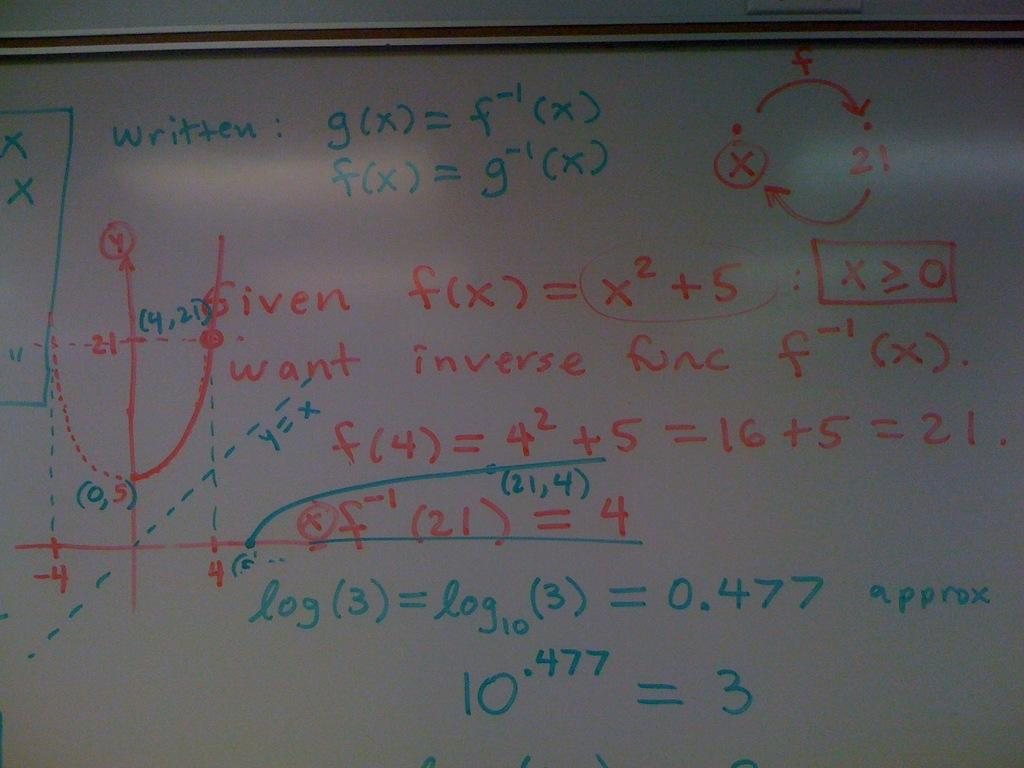<image>
Present a compact description of the photo's key features. A whiteboard with inverse and log math functions. 